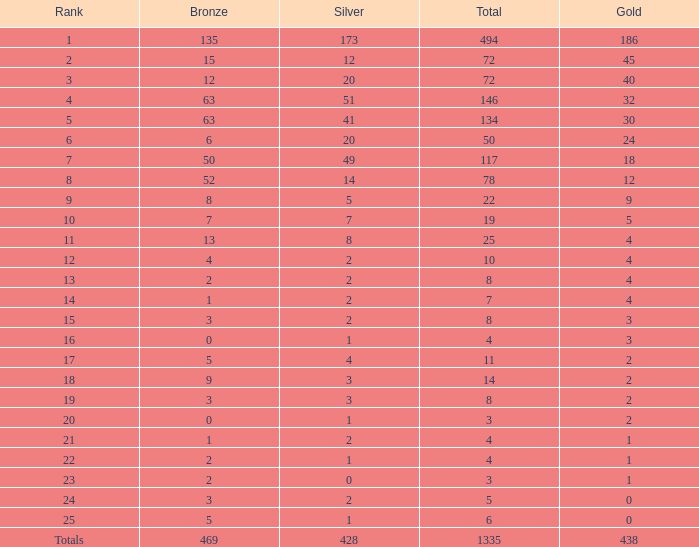What is the average number of gold medals when the total was 1335 medals, with more than 469 bronzes and more than 14 silvers? None. 